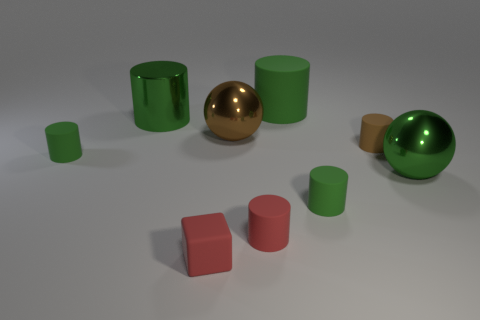Subtract all blue cubes. How many green cylinders are left? 4 Subtract all red cylinders. How many cylinders are left? 5 Subtract all green shiny cylinders. How many cylinders are left? 5 Subtract all gray cylinders. Subtract all brown spheres. How many cylinders are left? 6 Subtract all balls. How many objects are left? 7 Subtract 0 cyan cubes. How many objects are left? 9 Subtract all green cylinders. Subtract all tiny cylinders. How many objects are left? 1 Add 6 big brown shiny balls. How many big brown shiny balls are left? 7 Add 6 big green shiny balls. How many big green shiny balls exist? 7 